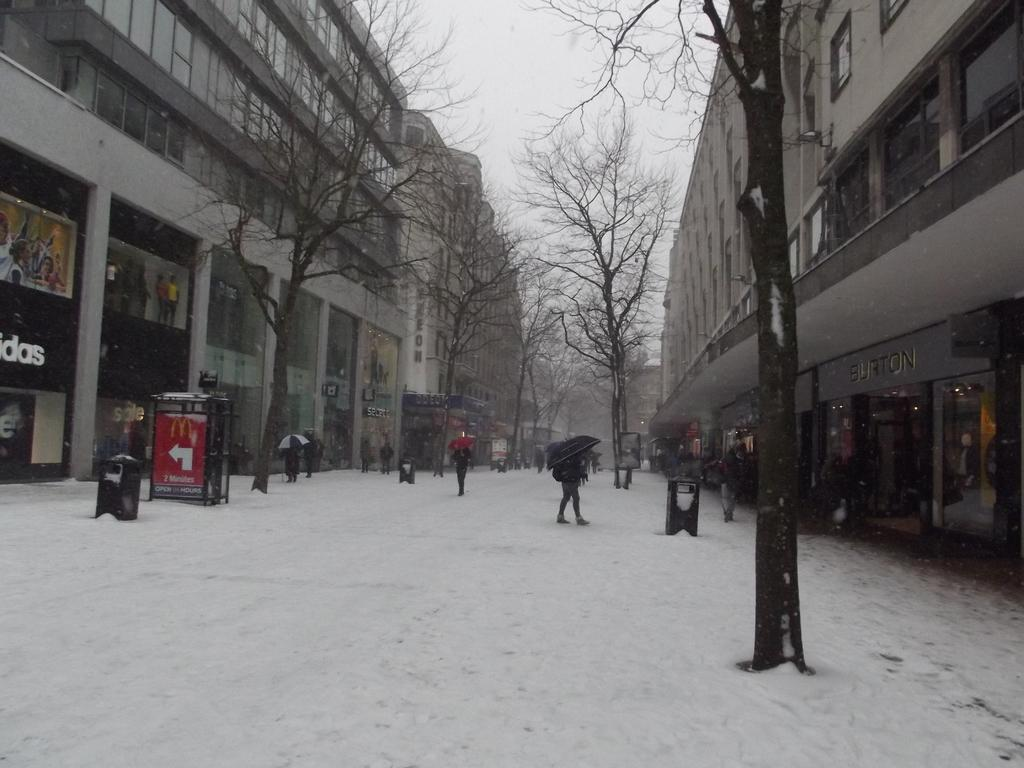How many people are in the image? There is a group of people in the image. What are the people doing in the image? The people are walking in the image. What are the people holding while walking? The people are holding umbrellas in the image. What is the weather like in the image? There is snow in the image, indicating a cold and likely snowy weather. What structures can be seen in the image? There are buildings in the image. What type of vegetation is present in the image? There are trees in the image. What can be seen in the background of the image? The sky is visible in the background of the image. What type of produce is being sold in the room in the image? There is no room or produce present in the image; it features a group of people walking with umbrellas in a snowy environment. What is the level of pollution in the image? The provided facts do not mention any pollution, so it cannot be determined from the image. 